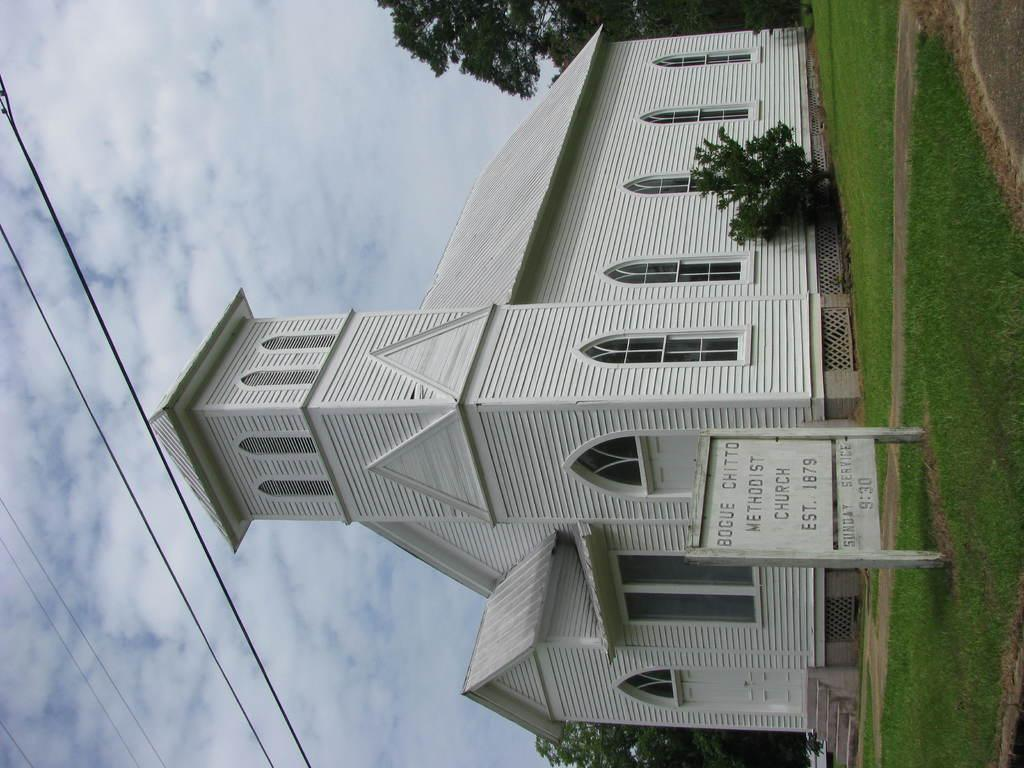<image>
Render a clear and concise summary of the photo. the word bogue is on the sign next to a church 